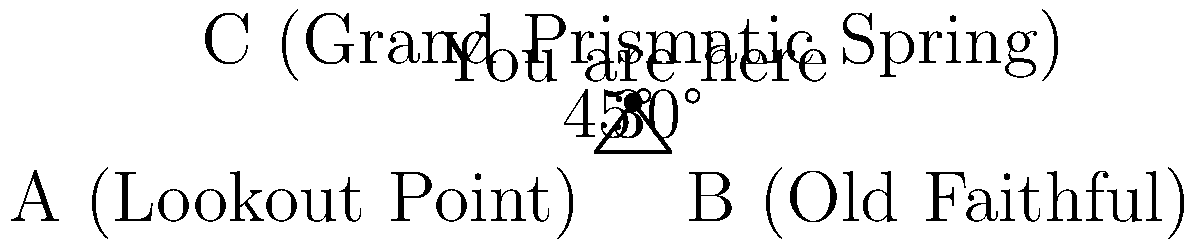You're at a scenic overlook in Yellowstone National Park, trying to determine your exact position. You can see two famous landmarks: the Old Faithful geyser and the Grand Prismatic Spring. Using your compass, you measure that the angle between Old Faithful and the lookout point is 30°, and the angle between the lookout point and the Grand Prismatic Spring is 45°. If the distance between the lookout point and Old Faithful is 6 miles, how far are you from the Grand Prismatic Spring? Let's solve this step-by-step using the law of sines:

1) Let's define our points:
   A: Lookout Point
   B: Old Faithful
   C: Your position (and the location of Grand Prismatic Spring)

2) We know:
   - Angle BAC = 30°
   - Angle ABC = 45°
   - Distance AB = 6 miles

3) The third angle of the triangle, BCA, can be calculated:
   BCA = 180° - 30° - 45° = 105°

4) Now we can use the law of sines:
   $$\frac{a}{\sin A} = \frac{b}{\sin B} = \frac{c}{\sin C}$$

   Where lowercase letters represent the side lengths opposite to the angles denoted by the corresponding uppercase letters.

5) We want to find AC (the distance to Grand Prismatic Spring). Let's call this distance x:
   $$\frac{6}{\sin 105°} = \frac{x}{\sin 30°}$$

6) Cross multiply:
   $$6 \sin 30° = x \sin 105°$$

7) Solve for x:
   $$x = \frac{6 \sin 30°}{\sin 105°}$$

8) Calculate (you can use a calculator):
   $$x \approx 3.86$$

Therefore, you are approximately 3.86 miles from the Grand Prismatic Spring.
Answer: 3.86 miles 